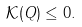Convert formula to latex. <formula><loc_0><loc_0><loc_500><loc_500>\mathcal { K } ( Q ) \leq 0 .</formula> 